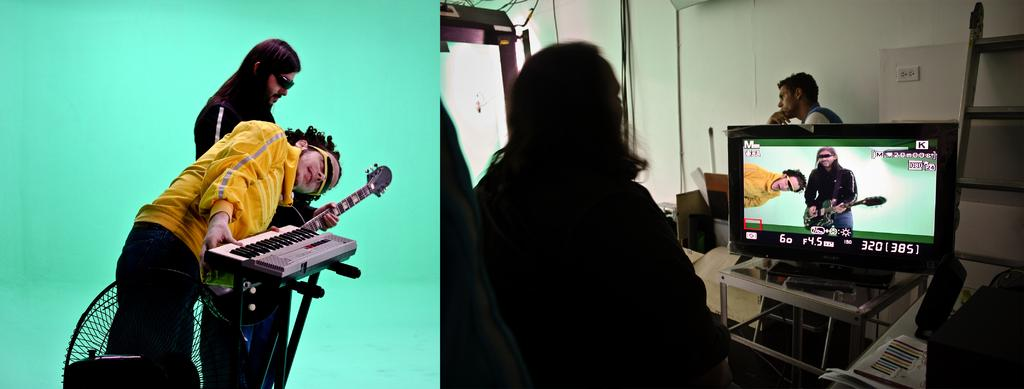What are the two musicians in the image doing? A man is playing guitar, and another man is playing keyboard. Can you describe the third person in the image? The third person is watching the performance on a TV screen. What is the net used for in the image? There is no net present in the image. What is the opinion of the third person about the performance? The provided facts do not mention the opinion of the third person about the performance. 